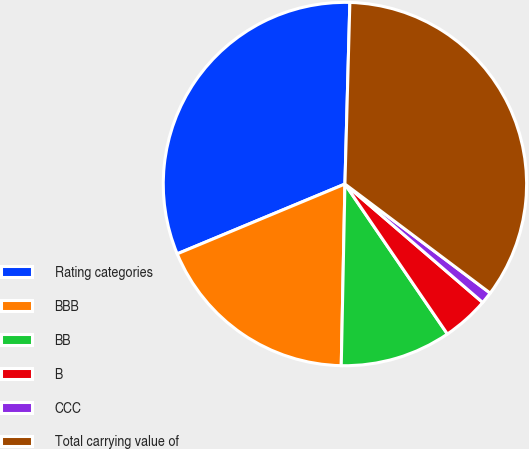Convert chart to OTSL. <chart><loc_0><loc_0><loc_500><loc_500><pie_chart><fcel>Rating categories<fcel>BBB<fcel>BB<fcel>B<fcel>CCC<fcel>Total carrying value of<nl><fcel>31.71%<fcel>18.4%<fcel>9.86%<fcel>4.16%<fcel>1.05%<fcel>34.82%<nl></chart> 